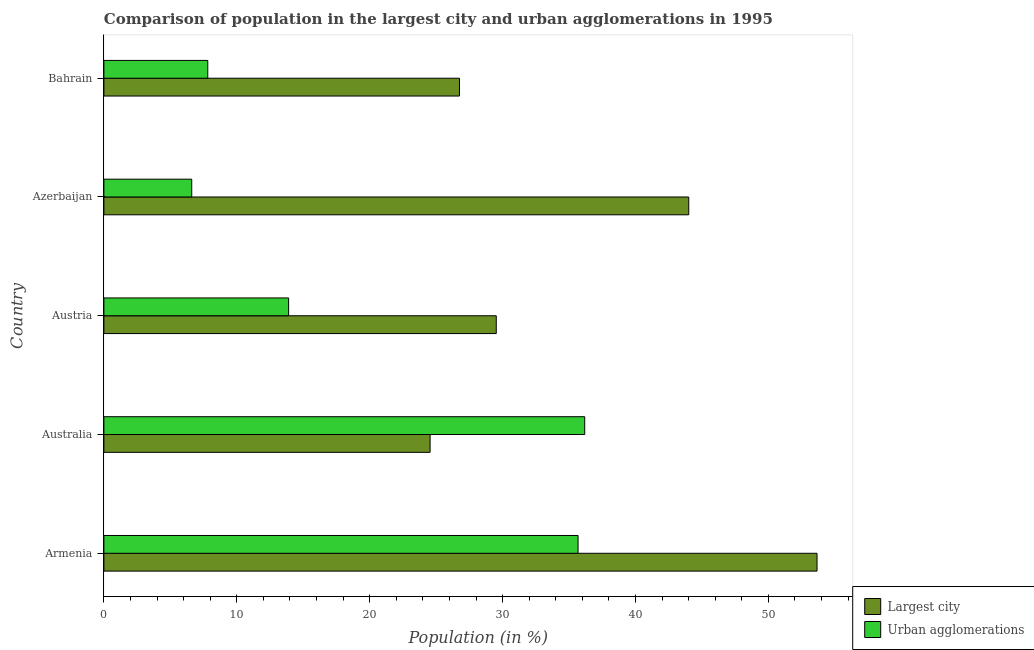How many groups of bars are there?
Offer a terse response. 5. How many bars are there on the 5th tick from the bottom?
Provide a succinct answer. 2. What is the label of the 1st group of bars from the top?
Your response must be concise. Bahrain. What is the population in urban agglomerations in Bahrain?
Provide a succinct answer. 7.82. Across all countries, what is the maximum population in the largest city?
Offer a very short reply. 53.66. Across all countries, what is the minimum population in urban agglomerations?
Your response must be concise. 6.61. In which country was the population in urban agglomerations maximum?
Make the answer very short. Australia. In which country was the population in urban agglomerations minimum?
Offer a very short reply. Azerbaijan. What is the total population in urban agglomerations in the graph?
Offer a very short reply. 100.18. What is the difference between the population in urban agglomerations in Armenia and that in Bahrain?
Your response must be concise. 27.86. What is the difference between the population in urban agglomerations in Australia and the population in the largest city in Bahrain?
Provide a short and direct response. 9.42. What is the average population in the largest city per country?
Provide a short and direct response. 35.7. What is the difference between the population in the largest city and population in urban agglomerations in Austria?
Ensure brevity in your answer.  15.62. In how many countries, is the population in the largest city greater than 28 %?
Provide a succinct answer. 3. What is the ratio of the population in the largest city in Azerbaijan to that in Bahrain?
Your response must be concise. 1.65. Is the population in the largest city in Australia less than that in Austria?
Provide a short and direct response. Yes. What is the difference between the highest and the second highest population in the largest city?
Offer a very short reply. 9.65. What is the difference between the highest and the lowest population in the largest city?
Provide a succinct answer. 29.12. In how many countries, is the population in the largest city greater than the average population in the largest city taken over all countries?
Provide a succinct answer. 2. Is the sum of the population in urban agglomerations in Australia and Bahrain greater than the maximum population in the largest city across all countries?
Make the answer very short. No. What does the 2nd bar from the top in Armenia represents?
Your answer should be compact. Largest city. What does the 2nd bar from the bottom in Austria represents?
Keep it short and to the point. Urban agglomerations. How many bars are there?
Keep it short and to the point. 10. Are all the bars in the graph horizontal?
Give a very brief answer. Yes. Where does the legend appear in the graph?
Provide a short and direct response. Bottom right. How are the legend labels stacked?
Keep it short and to the point. Vertical. What is the title of the graph?
Provide a succinct answer. Comparison of population in the largest city and urban agglomerations in 1995. What is the label or title of the Y-axis?
Provide a succinct answer. Country. What is the Population (in %) in Largest city in Armenia?
Your response must be concise. 53.66. What is the Population (in %) in Urban agglomerations in Armenia?
Offer a very short reply. 35.68. What is the Population (in %) in Largest city in Australia?
Ensure brevity in your answer.  24.54. What is the Population (in %) in Urban agglomerations in Australia?
Ensure brevity in your answer.  36.18. What is the Population (in %) of Largest city in Austria?
Your response must be concise. 29.52. What is the Population (in %) of Urban agglomerations in Austria?
Offer a very short reply. 13.9. What is the Population (in %) in Largest city in Azerbaijan?
Offer a terse response. 44.01. What is the Population (in %) in Urban agglomerations in Azerbaijan?
Your answer should be compact. 6.61. What is the Population (in %) of Largest city in Bahrain?
Offer a very short reply. 26.76. What is the Population (in %) in Urban agglomerations in Bahrain?
Offer a very short reply. 7.82. Across all countries, what is the maximum Population (in %) of Largest city?
Ensure brevity in your answer.  53.66. Across all countries, what is the maximum Population (in %) of Urban agglomerations?
Give a very brief answer. 36.18. Across all countries, what is the minimum Population (in %) in Largest city?
Provide a succinct answer. 24.54. Across all countries, what is the minimum Population (in %) of Urban agglomerations?
Provide a succinct answer. 6.61. What is the total Population (in %) in Largest city in the graph?
Provide a succinct answer. 178.49. What is the total Population (in %) in Urban agglomerations in the graph?
Your answer should be compact. 100.18. What is the difference between the Population (in %) in Largest city in Armenia and that in Australia?
Provide a short and direct response. 29.12. What is the difference between the Population (in %) of Urban agglomerations in Armenia and that in Australia?
Ensure brevity in your answer.  -0.5. What is the difference between the Population (in %) of Largest city in Armenia and that in Austria?
Keep it short and to the point. 24.14. What is the difference between the Population (in %) in Urban agglomerations in Armenia and that in Austria?
Give a very brief answer. 21.78. What is the difference between the Population (in %) of Largest city in Armenia and that in Azerbaijan?
Offer a very short reply. 9.65. What is the difference between the Population (in %) of Urban agglomerations in Armenia and that in Azerbaijan?
Keep it short and to the point. 29.07. What is the difference between the Population (in %) of Largest city in Armenia and that in Bahrain?
Keep it short and to the point. 26.9. What is the difference between the Population (in %) of Urban agglomerations in Armenia and that in Bahrain?
Your response must be concise. 27.86. What is the difference between the Population (in %) of Largest city in Australia and that in Austria?
Provide a succinct answer. -4.98. What is the difference between the Population (in %) in Urban agglomerations in Australia and that in Austria?
Offer a terse response. 22.28. What is the difference between the Population (in %) in Largest city in Australia and that in Azerbaijan?
Ensure brevity in your answer.  -19.46. What is the difference between the Population (in %) of Urban agglomerations in Australia and that in Azerbaijan?
Your answer should be compact. 29.57. What is the difference between the Population (in %) of Largest city in Australia and that in Bahrain?
Provide a succinct answer. -2.21. What is the difference between the Population (in %) in Urban agglomerations in Australia and that in Bahrain?
Keep it short and to the point. 28.36. What is the difference between the Population (in %) in Largest city in Austria and that in Azerbaijan?
Give a very brief answer. -14.48. What is the difference between the Population (in %) in Urban agglomerations in Austria and that in Azerbaijan?
Provide a short and direct response. 7.29. What is the difference between the Population (in %) of Largest city in Austria and that in Bahrain?
Offer a very short reply. 2.77. What is the difference between the Population (in %) in Urban agglomerations in Austria and that in Bahrain?
Give a very brief answer. 6.08. What is the difference between the Population (in %) in Largest city in Azerbaijan and that in Bahrain?
Provide a succinct answer. 17.25. What is the difference between the Population (in %) of Urban agglomerations in Azerbaijan and that in Bahrain?
Provide a succinct answer. -1.21. What is the difference between the Population (in %) in Largest city in Armenia and the Population (in %) in Urban agglomerations in Australia?
Give a very brief answer. 17.48. What is the difference between the Population (in %) of Largest city in Armenia and the Population (in %) of Urban agglomerations in Austria?
Ensure brevity in your answer.  39.76. What is the difference between the Population (in %) in Largest city in Armenia and the Population (in %) in Urban agglomerations in Azerbaijan?
Offer a terse response. 47.05. What is the difference between the Population (in %) of Largest city in Armenia and the Population (in %) of Urban agglomerations in Bahrain?
Offer a terse response. 45.84. What is the difference between the Population (in %) in Largest city in Australia and the Population (in %) in Urban agglomerations in Austria?
Offer a very short reply. 10.64. What is the difference between the Population (in %) of Largest city in Australia and the Population (in %) of Urban agglomerations in Azerbaijan?
Your response must be concise. 17.93. What is the difference between the Population (in %) of Largest city in Australia and the Population (in %) of Urban agglomerations in Bahrain?
Offer a terse response. 16.73. What is the difference between the Population (in %) in Largest city in Austria and the Population (in %) in Urban agglomerations in Azerbaijan?
Give a very brief answer. 22.91. What is the difference between the Population (in %) in Largest city in Austria and the Population (in %) in Urban agglomerations in Bahrain?
Offer a terse response. 21.71. What is the difference between the Population (in %) of Largest city in Azerbaijan and the Population (in %) of Urban agglomerations in Bahrain?
Give a very brief answer. 36.19. What is the average Population (in %) in Largest city per country?
Your response must be concise. 35.7. What is the average Population (in %) in Urban agglomerations per country?
Offer a very short reply. 20.04. What is the difference between the Population (in %) of Largest city and Population (in %) of Urban agglomerations in Armenia?
Ensure brevity in your answer.  17.98. What is the difference between the Population (in %) in Largest city and Population (in %) in Urban agglomerations in Australia?
Offer a very short reply. -11.63. What is the difference between the Population (in %) in Largest city and Population (in %) in Urban agglomerations in Austria?
Keep it short and to the point. 15.62. What is the difference between the Population (in %) in Largest city and Population (in %) in Urban agglomerations in Azerbaijan?
Keep it short and to the point. 37.4. What is the difference between the Population (in %) of Largest city and Population (in %) of Urban agglomerations in Bahrain?
Your answer should be very brief. 18.94. What is the ratio of the Population (in %) in Largest city in Armenia to that in Australia?
Offer a very short reply. 2.19. What is the ratio of the Population (in %) in Urban agglomerations in Armenia to that in Australia?
Offer a terse response. 0.99. What is the ratio of the Population (in %) in Largest city in Armenia to that in Austria?
Keep it short and to the point. 1.82. What is the ratio of the Population (in %) of Urban agglomerations in Armenia to that in Austria?
Your response must be concise. 2.57. What is the ratio of the Population (in %) in Largest city in Armenia to that in Azerbaijan?
Offer a very short reply. 1.22. What is the ratio of the Population (in %) of Urban agglomerations in Armenia to that in Azerbaijan?
Your answer should be compact. 5.4. What is the ratio of the Population (in %) of Largest city in Armenia to that in Bahrain?
Give a very brief answer. 2.01. What is the ratio of the Population (in %) in Urban agglomerations in Armenia to that in Bahrain?
Offer a terse response. 4.56. What is the ratio of the Population (in %) of Largest city in Australia to that in Austria?
Offer a very short reply. 0.83. What is the ratio of the Population (in %) in Urban agglomerations in Australia to that in Austria?
Make the answer very short. 2.6. What is the ratio of the Population (in %) of Largest city in Australia to that in Azerbaijan?
Your answer should be very brief. 0.56. What is the ratio of the Population (in %) in Urban agglomerations in Australia to that in Azerbaijan?
Your response must be concise. 5.47. What is the ratio of the Population (in %) of Largest city in Australia to that in Bahrain?
Provide a succinct answer. 0.92. What is the ratio of the Population (in %) in Urban agglomerations in Australia to that in Bahrain?
Your response must be concise. 4.63. What is the ratio of the Population (in %) in Largest city in Austria to that in Azerbaijan?
Ensure brevity in your answer.  0.67. What is the ratio of the Population (in %) of Urban agglomerations in Austria to that in Azerbaijan?
Give a very brief answer. 2.1. What is the ratio of the Population (in %) of Largest city in Austria to that in Bahrain?
Provide a succinct answer. 1.1. What is the ratio of the Population (in %) of Urban agglomerations in Austria to that in Bahrain?
Give a very brief answer. 1.78. What is the ratio of the Population (in %) of Largest city in Azerbaijan to that in Bahrain?
Provide a succinct answer. 1.64. What is the ratio of the Population (in %) in Urban agglomerations in Azerbaijan to that in Bahrain?
Keep it short and to the point. 0.85. What is the difference between the highest and the second highest Population (in %) of Largest city?
Offer a very short reply. 9.65. What is the difference between the highest and the second highest Population (in %) of Urban agglomerations?
Ensure brevity in your answer.  0.5. What is the difference between the highest and the lowest Population (in %) of Largest city?
Make the answer very short. 29.12. What is the difference between the highest and the lowest Population (in %) of Urban agglomerations?
Provide a short and direct response. 29.57. 